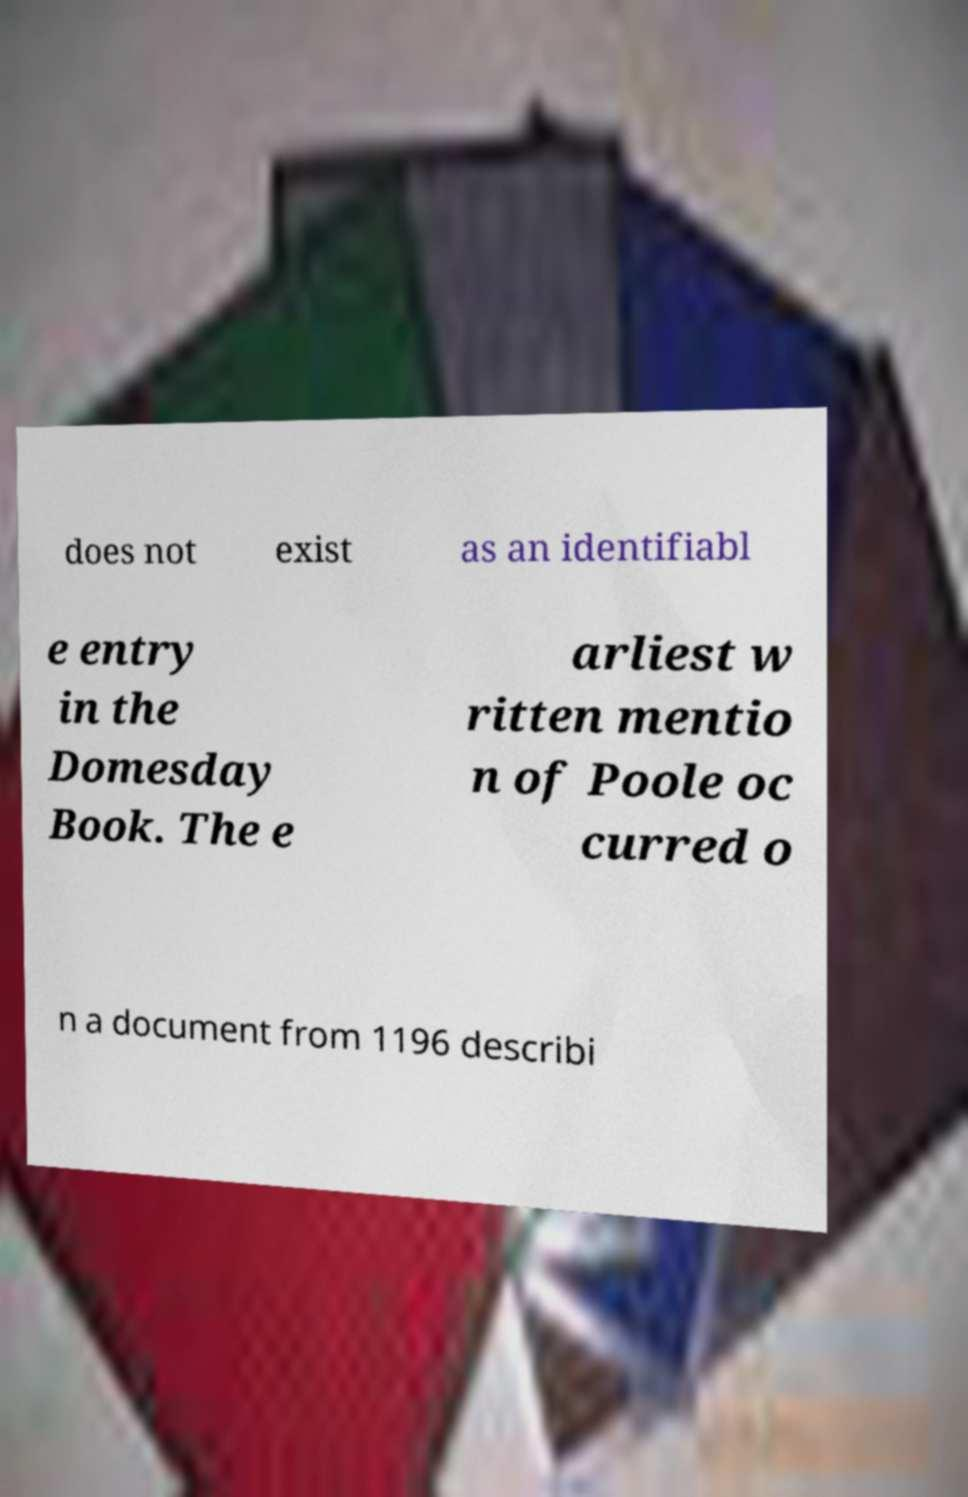I need the written content from this picture converted into text. Can you do that? does not exist as an identifiabl e entry in the Domesday Book. The e arliest w ritten mentio n of Poole oc curred o n a document from 1196 describi 